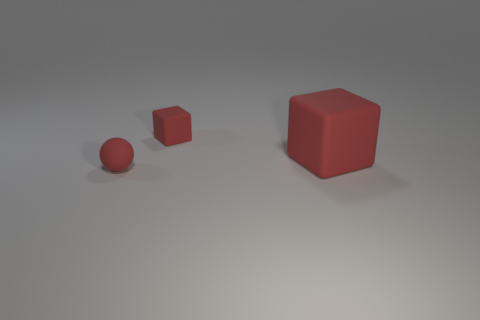The big thing that is the same color as the small rubber ball is what shape?
Ensure brevity in your answer.  Cube. Is there any other thing of the same color as the large object?
Provide a succinct answer. Yes. Is the color of the big cube the same as the tiny matte ball that is left of the big red rubber block?
Your answer should be compact. Yes. What number of things are either red balls in front of the tiny red matte cube or red matte things in front of the tiny red matte cube?
Provide a succinct answer. 2. Is the number of small red objects to the right of the tiny ball greater than the number of large red objects right of the large rubber thing?
Give a very brief answer. Yes. There is a small object to the right of the small red sphere; is it the same shape as the tiny red rubber object left of the small matte cube?
Offer a terse response. No. Is there a red thing that has the same size as the matte ball?
Offer a very short reply. Yes. What number of brown objects are tiny rubber things or metallic cubes?
Keep it short and to the point. 0. How many small rubber cubes have the same color as the big cube?
Provide a succinct answer. 1. What number of cylinders are either small red matte things or red objects?
Your answer should be compact. 0. 